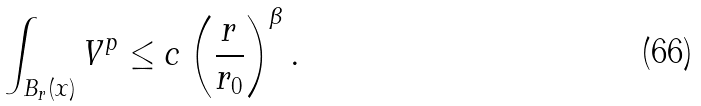Convert formula to latex. <formula><loc_0><loc_0><loc_500><loc_500>\int _ { B _ { r } ( x ) } V ^ { p } \leq c \left ( \frac { r } { r _ { 0 } } \right ) ^ { \beta } .</formula> 